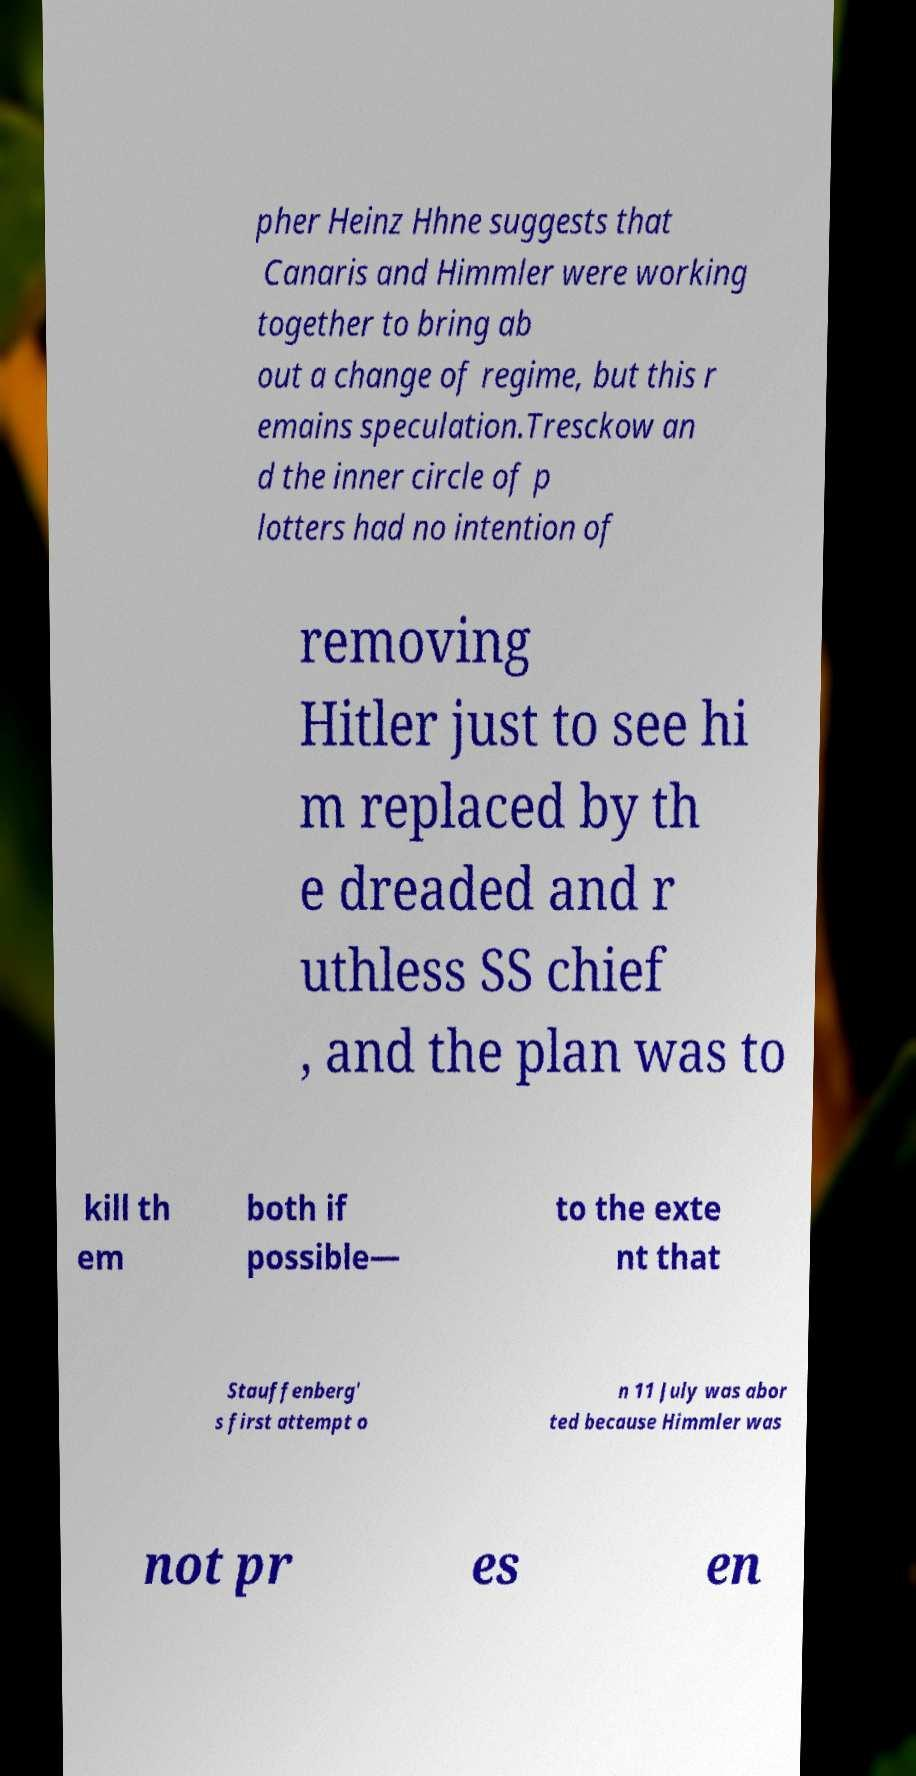Please read and relay the text visible in this image. What does it say? pher Heinz Hhne suggests that Canaris and Himmler were working together to bring ab out a change of regime, but this r emains speculation.Tresckow an d the inner circle of p lotters had no intention of removing Hitler just to see hi m replaced by th e dreaded and r uthless SS chief , and the plan was to kill th em both if possible— to the exte nt that Stauffenberg' s first attempt o n 11 July was abor ted because Himmler was not pr es en 